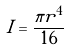Convert formula to latex. <formula><loc_0><loc_0><loc_500><loc_500>I = \frac { \pi r ^ { 4 } } { 1 6 }</formula> 